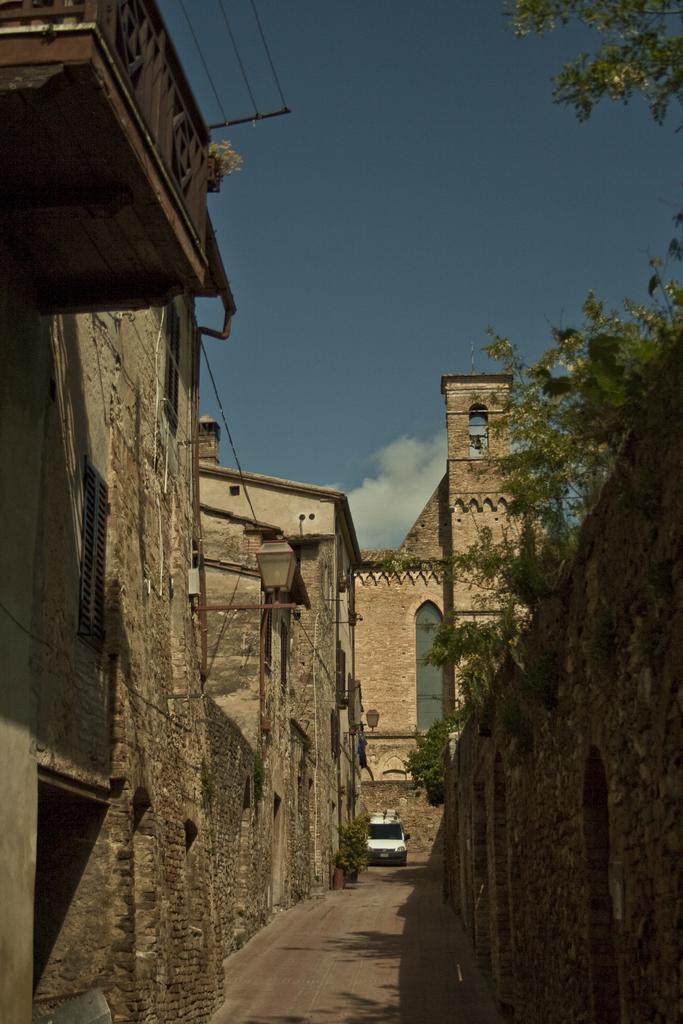Can you describe this image briefly? In this picture we can see a car on the road, trees, lamps, buildings with windows and in the background we can see the sky with clouds. 